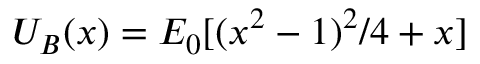<formula> <loc_0><loc_0><loc_500><loc_500>U _ { B } ( x ) = E _ { 0 } [ ( x ^ { 2 } - 1 ) ^ { 2 } / 4 + x ]</formula> 